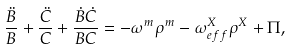<formula> <loc_0><loc_0><loc_500><loc_500>\frac { \ddot { B } } { B } + \frac { \ddot { C } } { C } + \frac { \dot { B } \dot { C } } { B C } = - \omega ^ { m } \rho ^ { m } - \omega ^ { X } _ { e f f } \rho ^ { X } + \Pi ,</formula> 